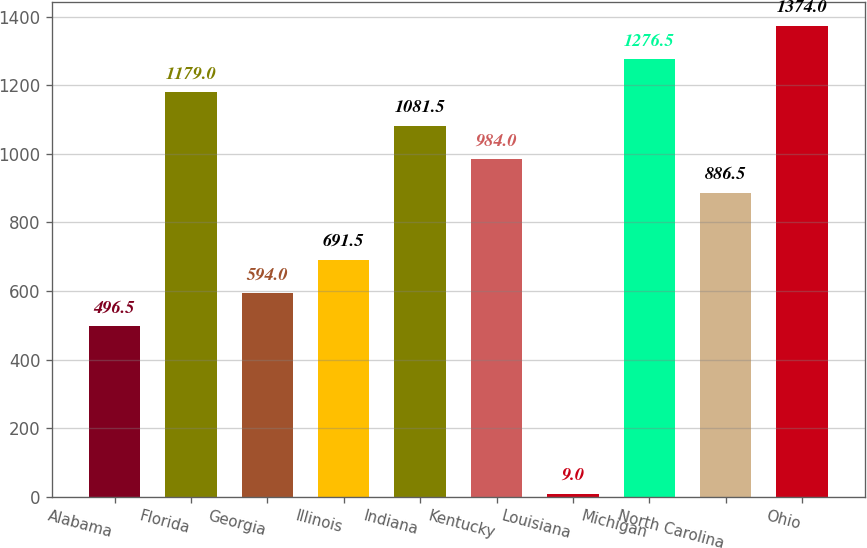Convert chart to OTSL. <chart><loc_0><loc_0><loc_500><loc_500><bar_chart><fcel>Alabama<fcel>Florida<fcel>Georgia<fcel>Illinois<fcel>Indiana<fcel>Kentucky<fcel>Louisiana<fcel>Michigan<fcel>North Carolina<fcel>Ohio<nl><fcel>496.5<fcel>1179<fcel>594<fcel>691.5<fcel>1081.5<fcel>984<fcel>9<fcel>1276.5<fcel>886.5<fcel>1374<nl></chart> 